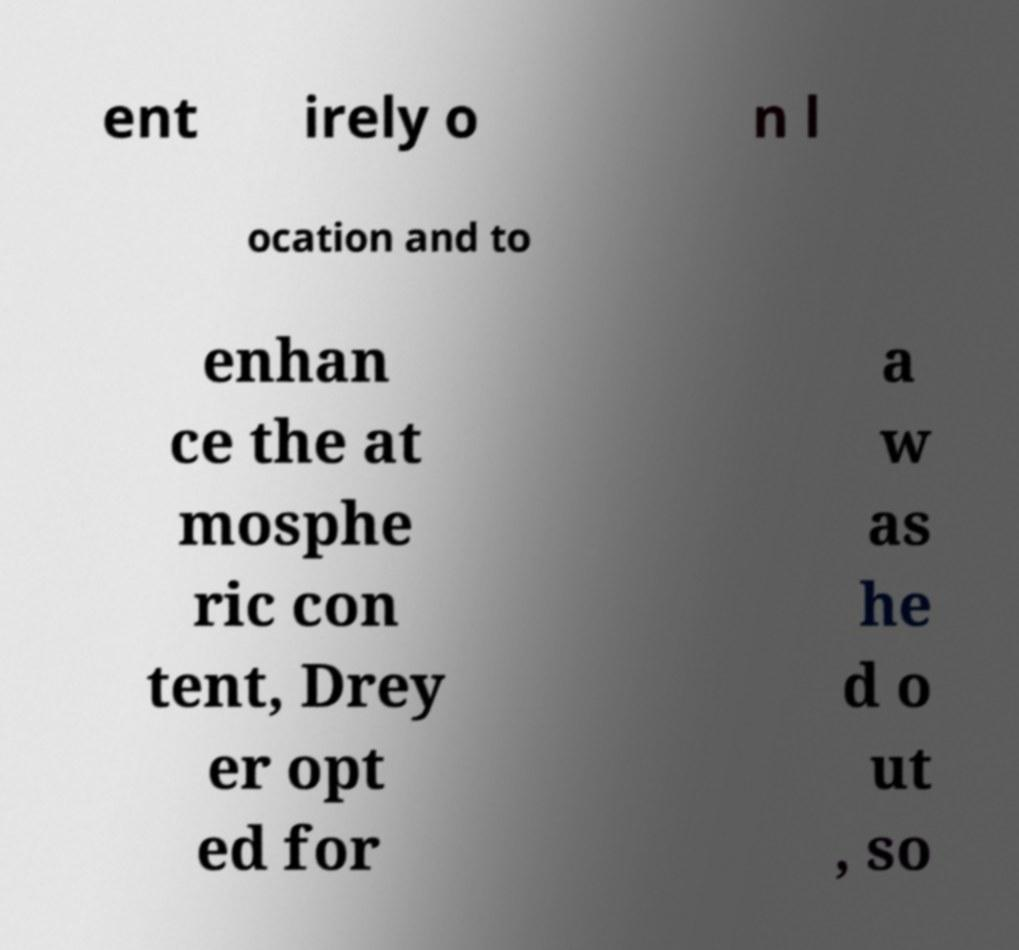Please read and relay the text visible in this image. What does it say? ent irely o n l ocation and to enhan ce the at mosphe ric con tent, Drey er opt ed for a w as he d o ut , so 